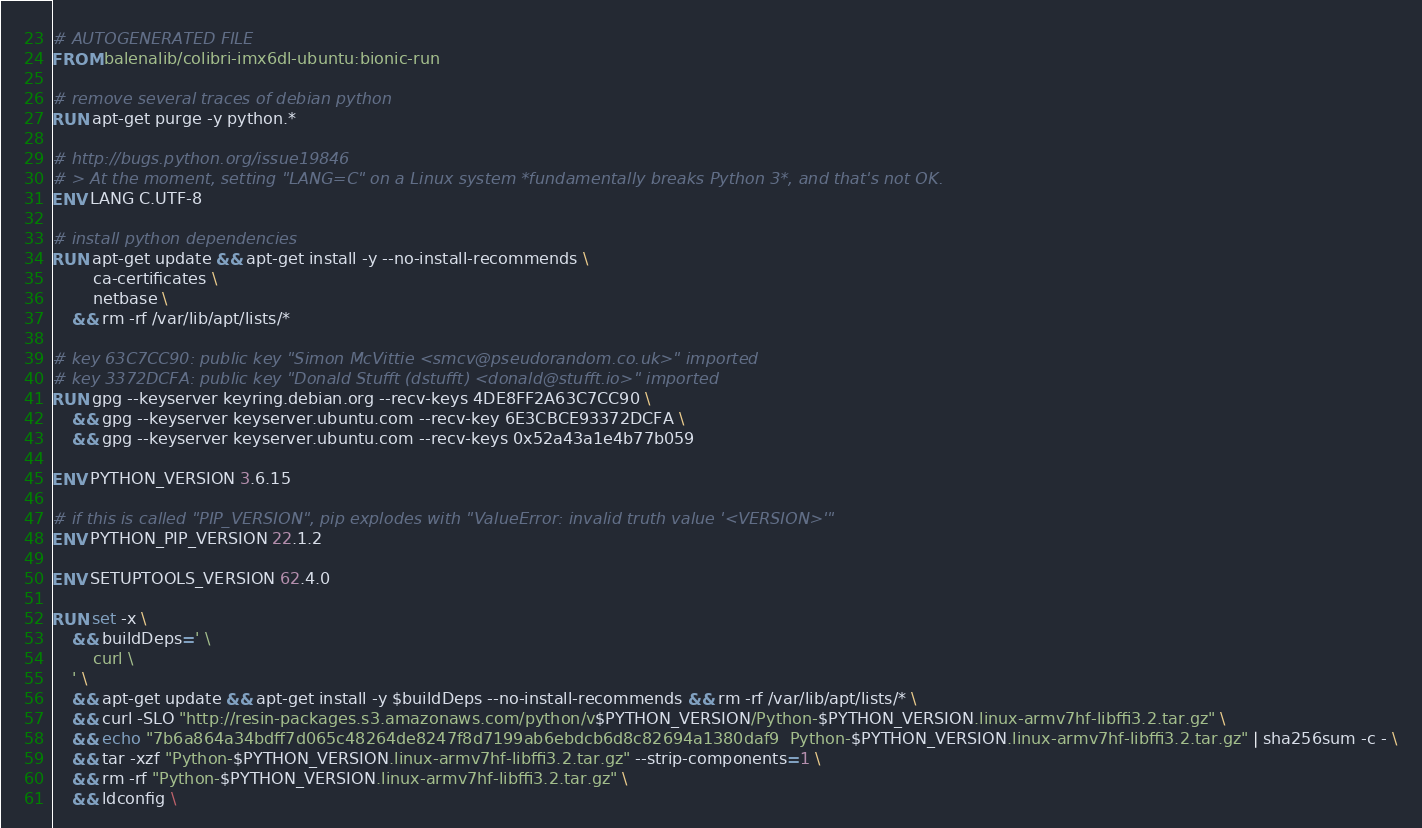Convert code to text. <code><loc_0><loc_0><loc_500><loc_500><_Dockerfile_># AUTOGENERATED FILE
FROM balenalib/colibri-imx6dl-ubuntu:bionic-run

# remove several traces of debian python
RUN apt-get purge -y python.*

# http://bugs.python.org/issue19846
# > At the moment, setting "LANG=C" on a Linux system *fundamentally breaks Python 3*, and that's not OK.
ENV LANG C.UTF-8

# install python dependencies
RUN apt-get update && apt-get install -y --no-install-recommends \
		ca-certificates \
		netbase \
	&& rm -rf /var/lib/apt/lists/*

# key 63C7CC90: public key "Simon McVittie <smcv@pseudorandom.co.uk>" imported
# key 3372DCFA: public key "Donald Stufft (dstufft) <donald@stufft.io>" imported
RUN gpg --keyserver keyring.debian.org --recv-keys 4DE8FF2A63C7CC90 \
	&& gpg --keyserver keyserver.ubuntu.com --recv-key 6E3CBCE93372DCFA \
	&& gpg --keyserver keyserver.ubuntu.com --recv-keys 0x52a43a1e4b77b059

ENV PYTHON_VERSION 3.6.15

# if this is called "PIP_VERSION", pip explodes with "ValueError: invalid truth value '<VERSION>'"
ENV PYTHON_PIP_VERSION 22.1.2

ENV SETUPTOOLS_VERSION 62.4.0

RUN set -x \
	&& buildDeps=' \
		curl \
	' \
	&& apt-get update && apt-get install -y $buildDeps --no-install-recommends && rm -rf /var/lib/apt/lists/* \
	&& curl -SLO "http://resin-packages.s3.amazonaws.com/python/v$PYTHON_VERSION/Python-$PYTHON_VERSION.linux-armv7hf-libffi3.2.tar.gz" \
	&& echo "7b6a864a34bdff7d065c48264de8247f8d7199ab6ebdcb6d8c82694a1380daf9  Python-$PYTHON_VERSION.linux-armv7hf-libffi3.2.tar.gz" | sha256sum -c - \
	&& tar -xzf "Python-$PYTHON_VERSION.linux-armv7hf-libffi3.2.tar.gz" --strip-components=1 \
	&& rm -rf "Python-$PYTHON_VERSION.linux-armv7hf-libffi3.2.tar.gz" \
	&& ldconfig \</code> 